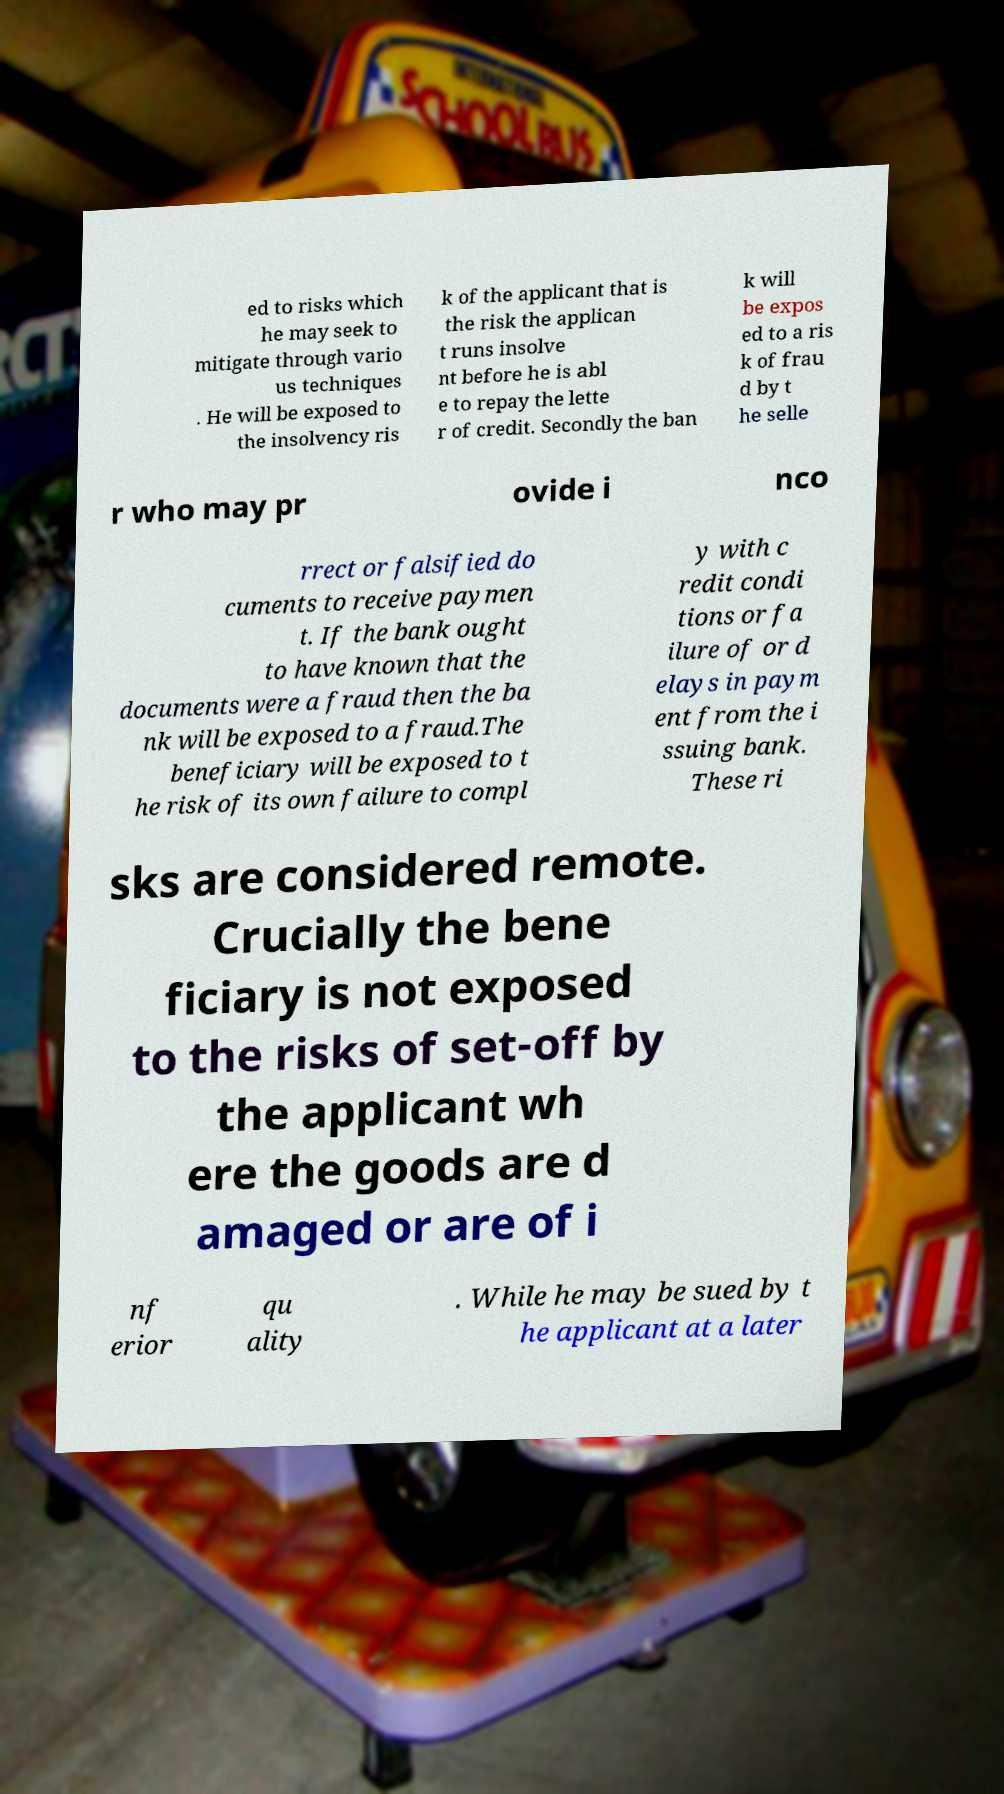Please read and relay the text visible in this image. What does it say? ed to risks which he may seek to mitigate through vario us techniques . He will be exposed to the insolvency ris k of the applicant that is the risk the applican t runs insolve nt before he is abl e to repay the lette r of credit. Secondly the ban k will be expos ed to a ris k of frau d by t he selle r who may pr ovide i nco rrect or falsified do cuments to receive paymen t. If the bank ought to have known that the documents were a fraud then the ba nk will be exposed to a fraud.The beneficiary will be exposed to t he risk of its own failure to compl y with c redit condi tions or fa ilure of or d elays in paym ent from the i ssuing bank. These ri sks are considered remote. Crucially the bene ficiary is not exposed to the risks of set-off by the applicant wh ere the goods are d amaged or are of i nf erior qu ality . While he may be sued by t he applicant at a later 